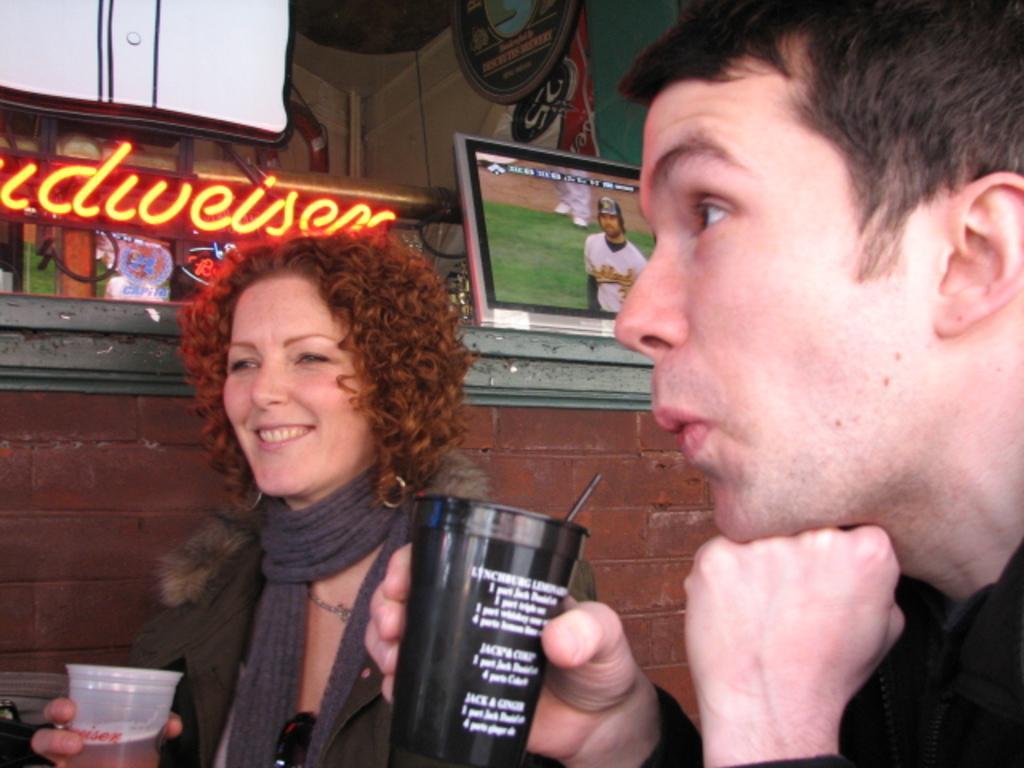Can you describe this image briefly? In the image there are two people both men and women are holding a glass. In background there is a brick wall,display,hoardings. 